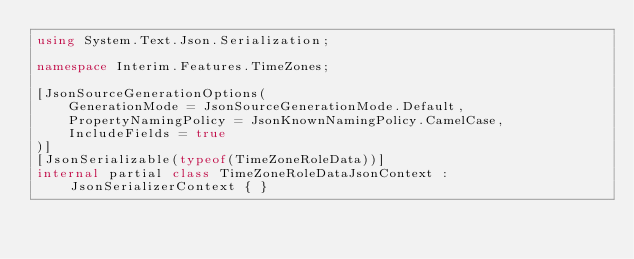Convert code to text. <code><loc_0><loc_0><loc_500><loc_500><_C#_>using System.Text.Json.Serialization;

namespace Interim.Features.TimeZones;

[JsonSourceGenerationOptions(
	GenerationMode = JsonSourceGenerationMode.Default,
	PropertyNamingPolicy = JsonKnownNamingPolicy.CamelCase, 
	IncludeFields = true
)]
[JsonSerializable(typeof(TimeZoneRoleData))]
internal partial class TimeZoneRoleDataJsonContext : JsonSerializerContext { }</code> 